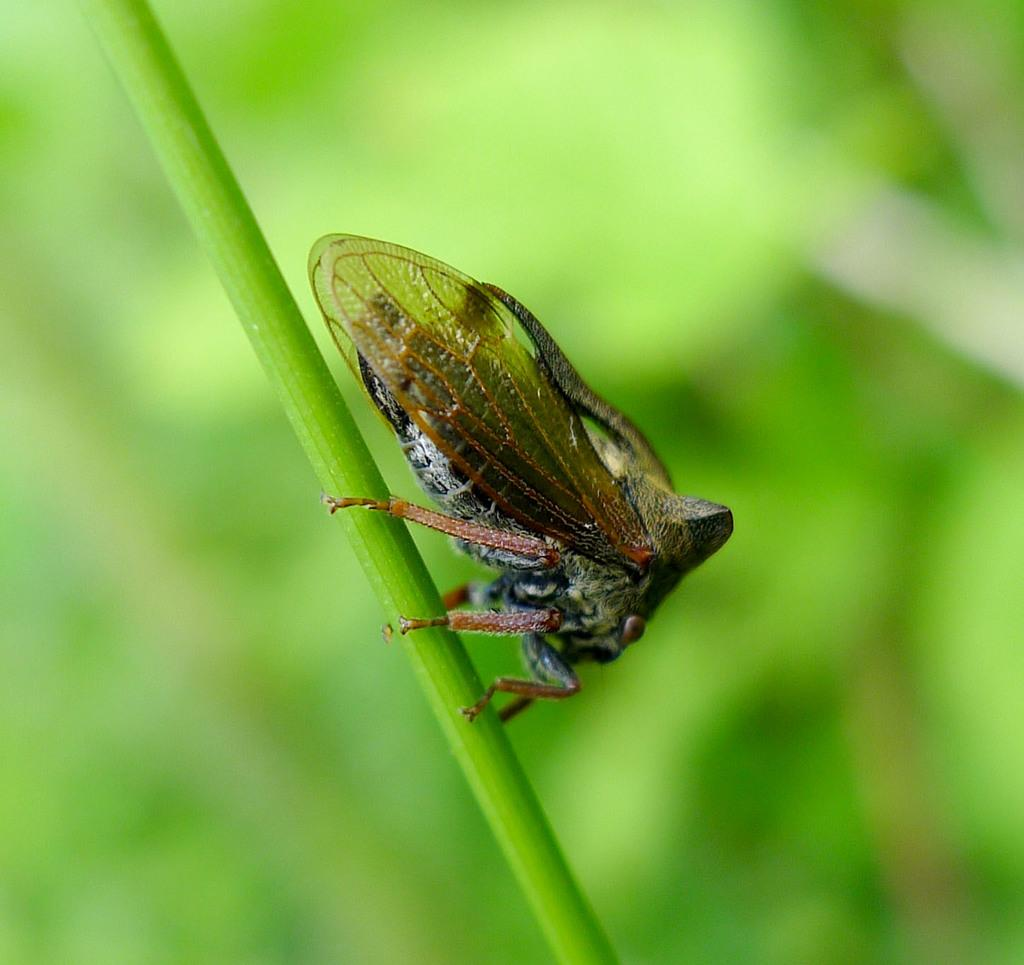What is present in the image? There is an insect in the image. What is the insect doing or resting on? The insect is on an object. Can you describe the background of the image? The background of the image is blurred. How many brothers does the insect have in the image? There is no information about the insect's family in the image, so it is impossible to determine the number of brothers it has. 